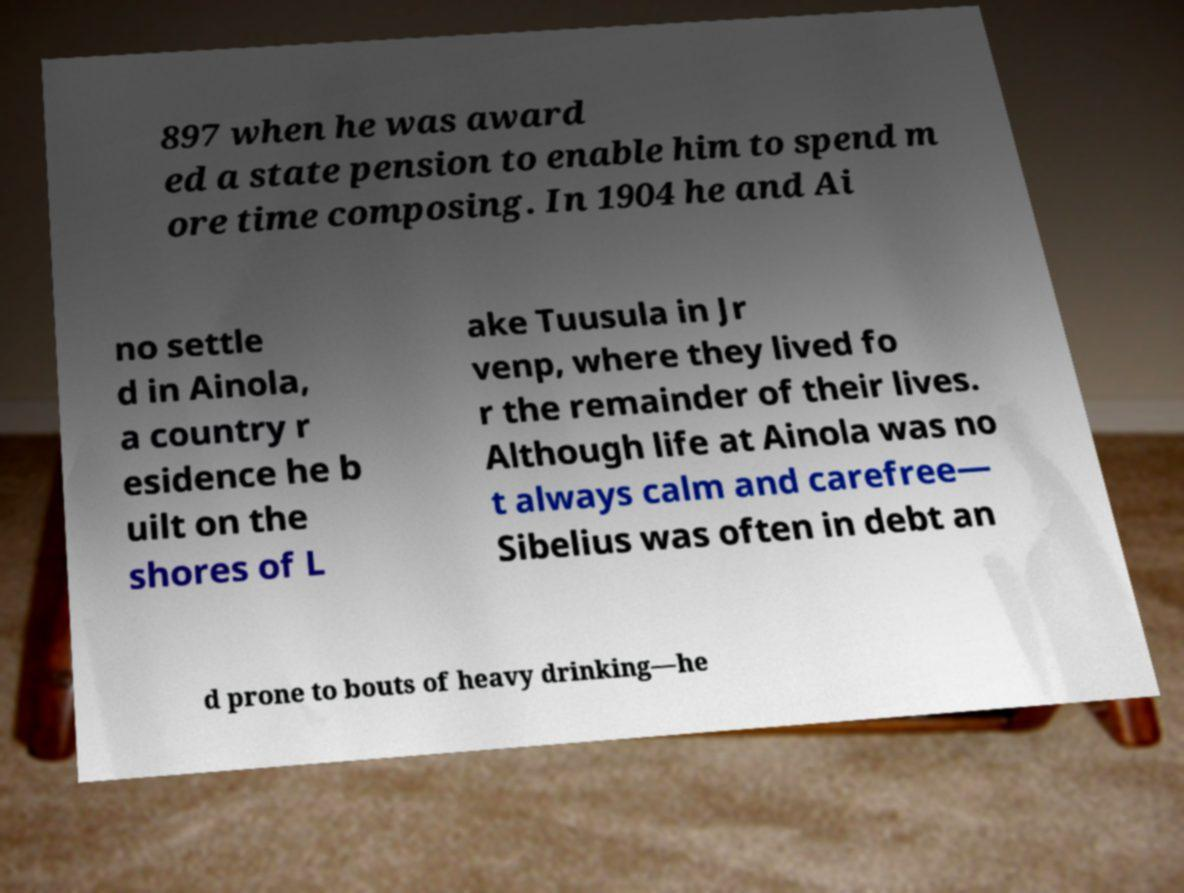What messages or text are displayed in this image? I need them in a readable, typed format. 897 when he was award ed a state pension to enable him to spend m ore time composing. In 1904 he and Ai no settle d in Ainola, a country r esidence he b uilt on the shores of L ake Tuusula in Jr venp, where they lived fo r the remainder of their lives. Although life at Ainola was no t always calm and carefree— Sibelius was often in debt an d prone to bouts of heavy drinking—he 